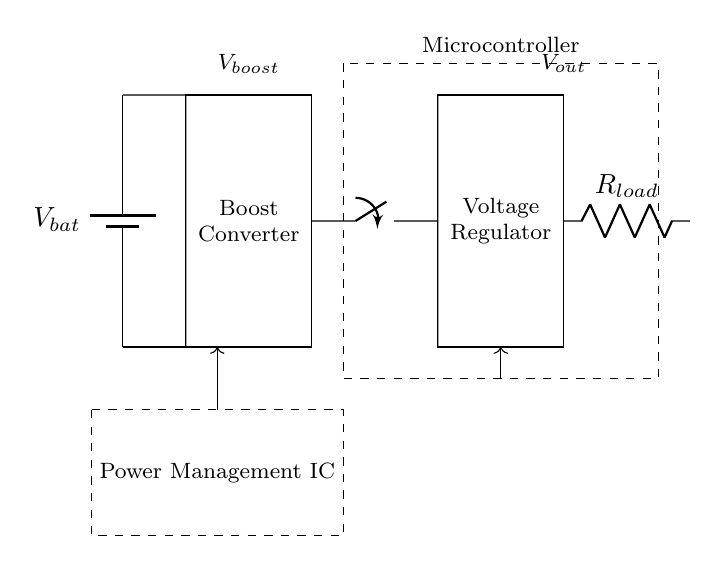What is the main function of the boost converter? The boost converter's function is to increase the voltage from the battery to a higher level needed for the load.
Answer: Increase voltage What does the load switch control? The load switch controls the connection between the power supply and the load, determining whether the load receives power or not.
Answer: Power to load What is the type of component labeled as R_load? R_load is a resistive component representing the load in this circuit.
Answer: Resistor What is the voltage output symbolized by V_out? V_out represents the voltage delivered to the load after regulation, which is critical for device operation.
Answer: Output voltage How does the power management IC connect with other components in the circuit? The power management IC connects the battery and the boost converter with input and output pathways, coordinating the supply of power.
Answer: Coordinates power supply What is the purpose of the voltage regulator? The voltage regulator stabilizes the output voltage to a specific level suitable for the connected load.
Answer: Stabilize voltage What could happen if the boost converter fails? If the boost converter fails, the voltage supplied to the load would drop, potentially causing the mobile device to malfunction due to insufficient power.
Answer: Device malfunction 